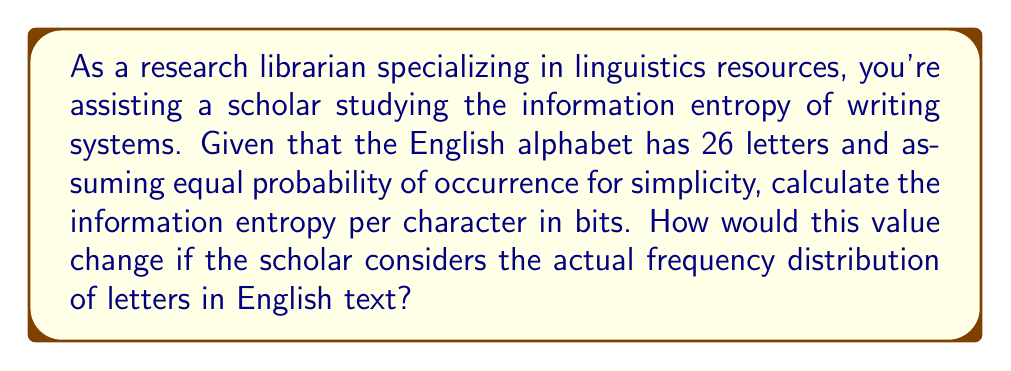Help me with this question. To solve this problem, we'll use principles from statistical mechanics and information theory:

1. For a system with equal probabilities:
   The information entropy is given by:
   $$S = -k \sum_{i=1}^{n} p_i \ln p_i$$
   where $k$ is Boltzmann's constant (which we'll take as 1 for information entropy), $n$ is the number of possible states, and $p_i$ is the probability of each state.

2. With 26 letters and equal probability:
   $$p_i = \frac{1}{26}$$ for all i

3. Substituting into the entropy formula:
   $$S = -\sum_{i=1}^{26} \frac{1}{26} \ln(\frac{1}{26})$$
   $$S = -26 \cdot \frac{1}{26} \ln(\frac{1}{26})$$
   $$S = -\ln(\frac{1}{26}) = \ln(26)$$

4. To convert to bits, divide by $\ln(2)$:
   $$S_{bits} = \frac{\ln(26)}{\ln(2)} \approx 4.7$$

5. For actual frequency distribution:
   The entropy would be lower because some letters are more common than others. The scholar would need to use the actual probabilities $p_i$ for each letter based on their frequency in English text. This would result in:
   $$S_{actual} = -\sum_{i=1}^{26} p_i \log_2(p_i)$$
   where $p_i$ is the actual probability of each letter.

   This value is typically around 4.1 bits per character for English text.
Answer: 4.7 bits per character (equal probability); ~4.1 bits per character (actual frequency) 